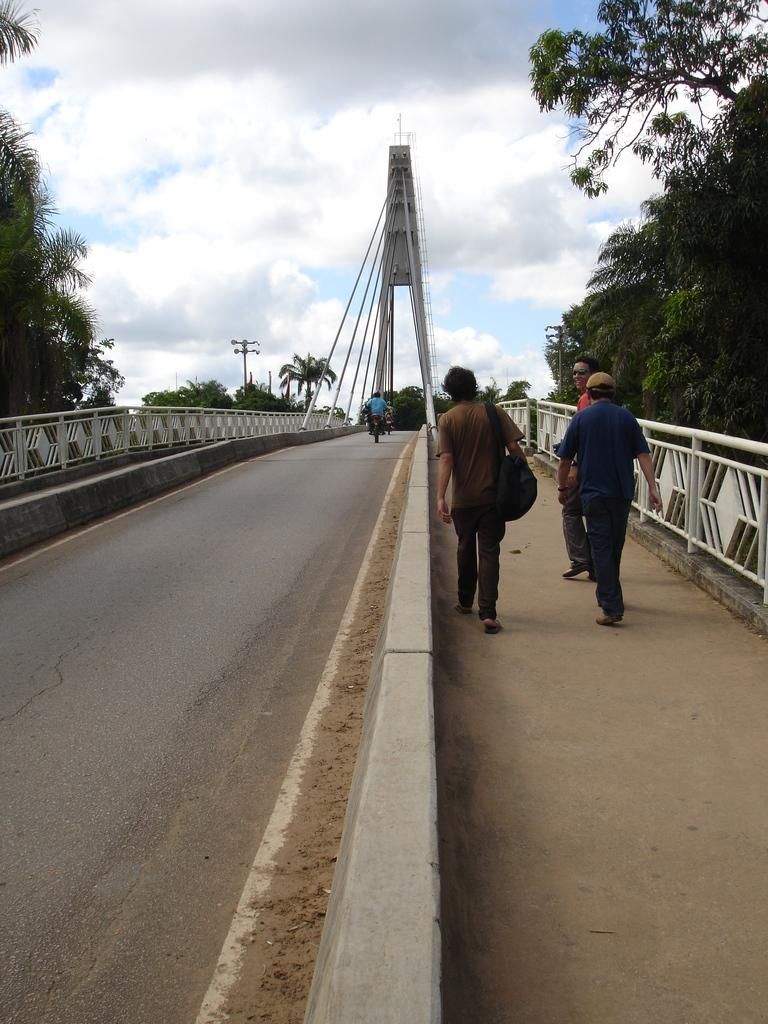What is the weather like in the image? The sky in the image appears cloudy, suggesting a potentially overcast or cloudy day. What is the tall structure in the image? There is a tower in the image. What are the long, thin objects in the image? Rods are present in the image. What might be used for safety or support in the image? Railings are visible in the image. How many people can be seen in the image? There are people in the image. What type of transportation is present in the image? A vehicle is present in the image. What is the vertical object in the image? There is a pole in the image. What type of vegetation is visible in the image? Trees are visible in the image. What type of flower is growing on the pole in the image? There is no flower growing on the pole in the image; it is a vertical object without any vegetation. 